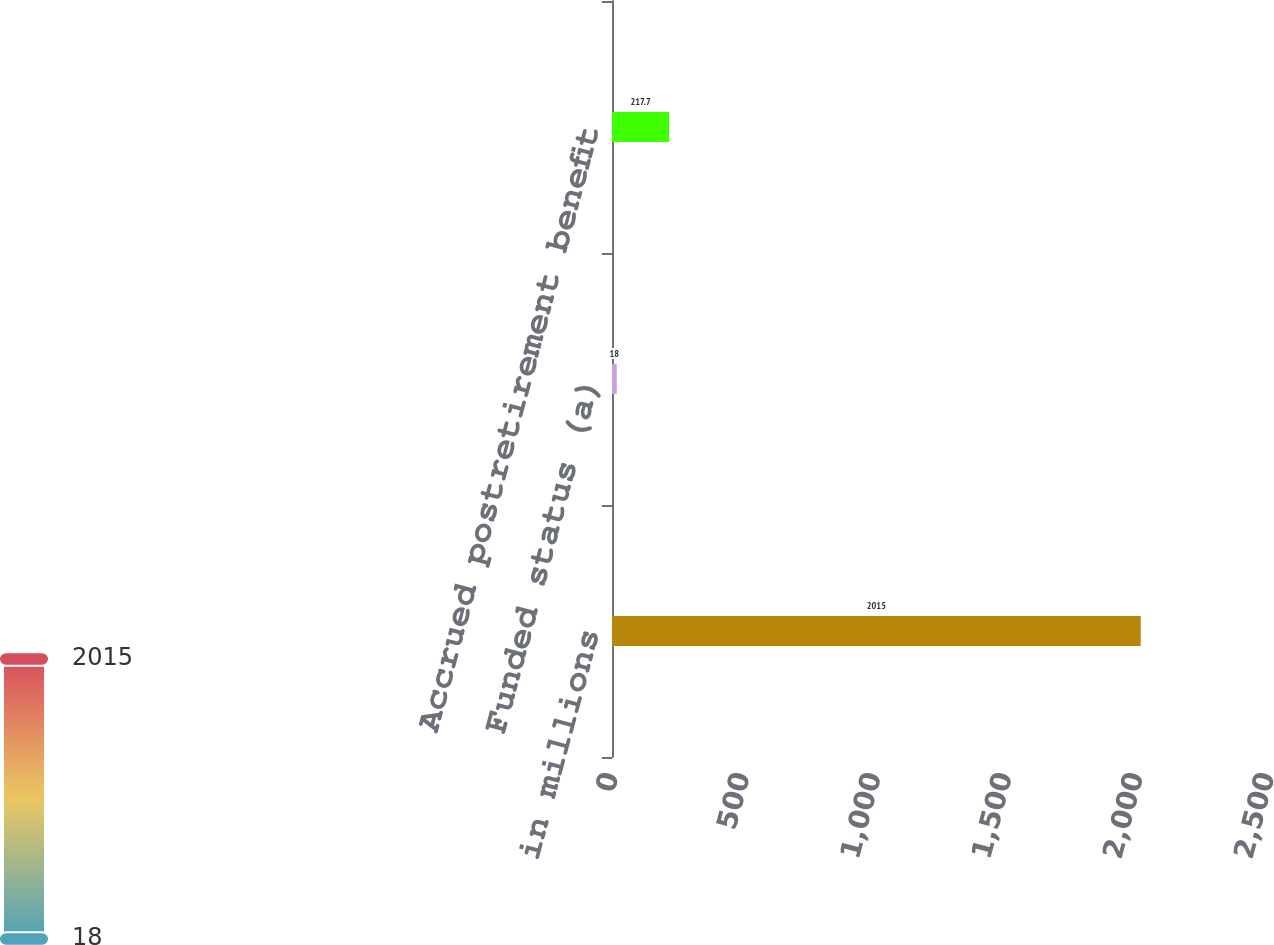Convert chart to OTSL. <chart><loc_0><loc_0><loc_500><loc_500><bar_chart><fcel>in millions<fcel>Funded status (a)<fcel>Accrued postretirement benefit<nl><fcel>2015<fcel>18<fcel>217.7<nl></chart> 